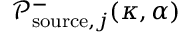Convert formula to latex. <formula><loc_0><loc_0><loc_500><loc_500>\mathcal { P } _ { s o u r c e , j } ^ { - } ( \kappa , \alpha )</formula> 